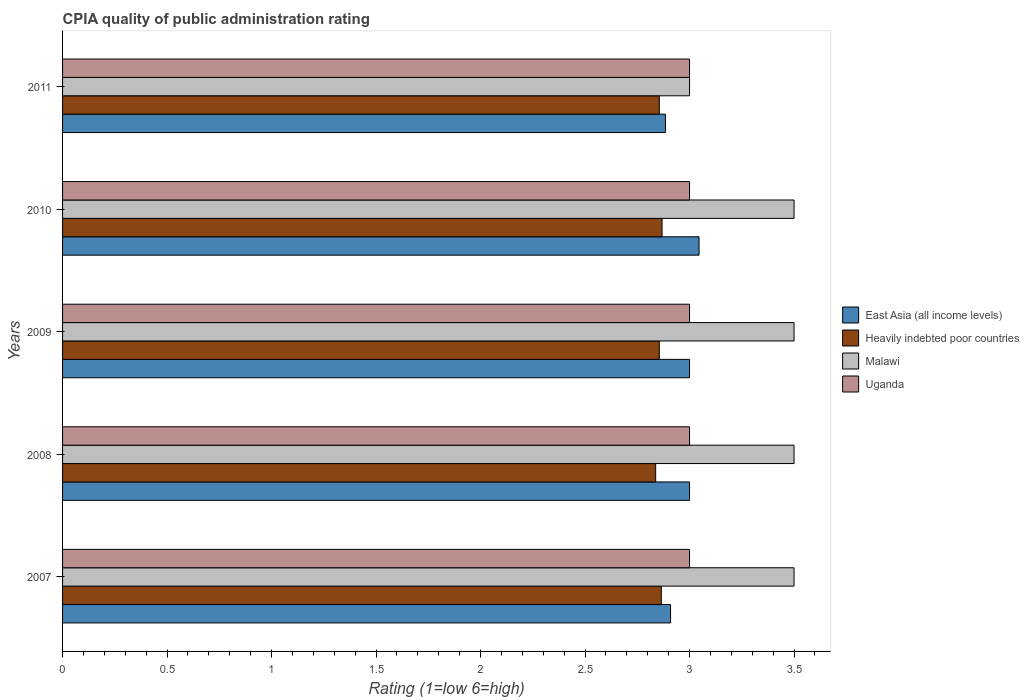Are the number of bars per tick equal to the number of legend labels?
Ensure brevity in your answer.  Yes. How many bars are there on the 4th tick from the top?
Give a very brief answer. 4. Across all years, what is the maximum CPIA rating in Heavily indebted poor countries?
Ensure brevity in your answer.  2.87. Across all years, what is the minimum CPIA rating in Malawi?
Provide a short and direct response. 3. In which year was the CPIA rating in Heavily indebted poor countries minimum?
Your answer should be very brief. 2008. What is the total CPIA rating in Uganda in the graph?
Your answer should be very brief. 15. In the year 2010, what is the difference between the CPIA rating in East Asia (all income levels) and CPIA rating in Heavily indebted poor countries?
Give a very brief answer. 0.18. In how many years, is the CPIA rating in Uganda greater than 1.4 ?
Ensure brevity in your answer.  5. Is the CPIA rating in East Asia (all income levels) in 2008 less than that in 2011?
Give a very brief answer. No. What is the difference between the highest and the second highest CPIA rating in Malawi?
Offer a very short reply. 0. Is it the case that in every year, the sum of the CPIA rating in Malawi and CPIA rating in Uganda is greater than the sum of CPIA rating in East Asia (all income levels) and CPIA rating in Heavily indebted poor countries?
Your answer should be very brief. Yes. What does the 2nd bar from the top in 2007 represents?
Provide a short and direct response. Malawi. What does the 2nd bar from the bottom in 2010 represents?
Provide a short and direct response. Heavily indebted poor countries. How many bars are there?
Give a very brief answer. 20. How many years are there in the graph?
Give a very brief answer. 5. What is the difference between two consecutive major ticks on the X-axis?
Ensure brevity in your answer.  0.5. Are the values on the major ticks of X-axis written in scientific E-notation?
Make the answer very short. No. Does the graph contain any zero values?
Provide a short and direct response. No. Does the graph contain grids?
Offer a very short reply. No. Where does the legend appear in the graph?
Offer a terse response. Center right. How many legend labels are there?
Your answer should be compact. 4. What is the title of the graph?
Your answer should be compact. CPIA quality of public administration rating. What is the label or title of the X-axis?
Provide a succinct answer. Rating (1=low 6=high). What is the label or title of the Y-axis?
Offer a terse response. Years. What is the Rating (1=low 6=high) in East Asia (all income levels) in 2007?
Make the answer very short. 2.91. What is the Rating (1=low 6=high) in Heavily indebted poor countries in 2007?
Offer a very short reply. 2.86. What is the Rating (1=low 6=high) in Uganda in 2007?
Your answer should be compact. 3. What is the Rating (1=low 6=high) in East Asia (all income levels) in 2008?
Your answer should be very brief. 3. What is the Rating (1=low 6=high) in Heavily indebted poor countries in 2008?
Offer a very short reply. 2.84. What is the Rating (1=low 6=high) in Malawi in 2008?
Provide a succinct answer. 3.5. What is the Rating (1=low 6=high) of Uganda in 2008?
Provide a succinct answer. 3. What is the Rating (1=low 6=high) in East Asia (all income levels) in 2009?
Make the answer very short. 3. What is the Rating (1=low 6=high) of Heavily indebted poor countries in 2009?
Offer a terse response. 2.86. What is the Rating (1=low 6=high) of East Asia (all income levels) in 2010?
Give a very brief answer. 3.05. What is the Rating (1=low 6=high) in Heavily indebted poor countries in 2010?
Make the answer very short. 2.87. What is the Rating (1=low 6=high) in Malawi in 2010?
Provide a succinct answer. 3.5. What is the Rating (1=low 6=high) of East Asia (all income levels) in 2011?
Make the answer very short. 2.88. What is the Rating (1=low 6=high) of Heavily indebted poor countries in 2011?
Your answer should be compact. 2.86. What is the Rating (1=low 6=high) of Uganda in 2011?
Ensure brevity in your answer.  3. Across all years, what is the maximum Rating (1=low 6=high) of East Asia (all income levels)?
Provide a succinct answer. 3.05. Across all years, what is the maximum Rating (1=low 6=high) in Heavily indebted poor countries?
Provide a short and direct response. 2.87. Across all years, what is the minimum Rating (1=low 6=high) of East Asia (all income levels)?
Ensure brevity in your answer.  2.88. Across all years, what is the minimum Rating (1=low 6=high) in Heavily indebted poor countries?
Make the answer very short. 2.84. Across all years, what is the minimum Rating (1=low 6=high) in Uganda?
Offer a terse response. 3. What is the total Rating (1=low 6=high) in East Asia (all income levels) in the graph?
Give a very brief answer. 14.84. What is the total Rating (1=low 6=high) of Heavily indebted poor countries in the graph?
Ensure brevity in your answer.  14.28. What is the total Rating (1=low 6=high) in Malawi in the graph?
Your answer should be very brief. 17. What is the difference between the Rating (1=low 6=high) of East Asia (all income levels) in 2007 and that in 2008?
Make the answer very short. -0.09. What is the difference between the Rating (1=low 6=high) in Heavily indebted poor countries in 2007 and that in 2008?
Provide a succinct answer. 0.03. What is the difference between the Rating (1=low 6=high) in East Asia (all income levels) in 2007 and that in 2009?
Your answer should be very brief. -0.09. What is the difference between the Rating (1=low 6=high) of Heavily indebted poor countries in 2007 and that in 2009?
Offer a very short reply. 0.01. What is the difference between the Rating (1=low 6=high) in East Asia (all income levels) in 2007 and that in 2010?
Ensure brevity in your answer.  -0.14. What is the difference between the Rating (1=low 6=high) of Heavily indebted poor countries in 2007 and that in 2010?
Your response must be concise. -0. What is the difference between the Rating (1=low 6=high) of Malawi in 2007 and that in 2010?
Give a very brief answer. 0. What is the difference between the Rating (1=low 6=high) in Uganda in 2007 and that in 2010?
Offer a very short reply. 0. What is the difference between the Rating (1=low 6=high) of East Asia (all income levels) in 2007 and that in 2011?
Give a very brief answer. 0.02. What is the difference between the Rating (1=low 6=high) of Heavily indebted poor countries in 2007 and that in 2011?
Make the answer very short. 0.01. What is the difference between the Rating (1=low 6=high) of Uganda in 2007 and that in 2011?
Your answer should be very brief. 0. What is the difference between the Rating (1=low 6=high) in East Asia (all income levels) in 2008 and that in 2009?
Your answer should be very brief. 0. What is the difference between the Rating (1=low 6=high) in Heavily indebted poor countries in 2008 and that in 2009?
Keep it short and to the point. -0.02. What is the difference between the Rating (1=low 6=high) in Malawi in 2008 and that in 2009?
Offer a terse response. 0. What is the difference between the Rating (1=low 6=high) of East Asia (all income levels) in 2008 and that in 2010?
Your answer should be very brief. -0.05. What is the difference between the Rating (1=low 6=high) in Heavily indebted poor countries in 2008 and that in 2010?
Give a very brief answer. -0.03. What is the difference between the Rating (1=low 6=high) of East Asia (all income levels) in 2008 and that in 2011?
Offer a terse response. 0.12. What is the difference between the Rating (1=low 6=high) of Heavily indebted poor countries in 2008 and that in 2011?
Provide a short and direct response. -0.02. What is the difference between the Rating (1=low 6=high) of East Asia (all income levels) in 2009 and that in 2010?
Provide a short and direct response. -0.05. What is the difference between the Rating (1=low 6=high) of Heavily indebted poor countries in 2009 and that in 2010?
Your response must be concise. -0.01. What is the difference between the Rating (1=low 6=high) in Malawi in 2009 and that in 2010?
Ensure brevity in your answer.  0. What is the difference between the Rating (1=low 6=high) in East Asia (all income levels) in 2009 and that in 2011?
Ensure brevity in your answer.  0.12. What is the difference between the Rating (1=low 6=high) in Heavily indebted poor countries in 2009 and that in 2011?
Provide a short and direct response. 0. What is the difference between the Rating (1=low 6=high) of Uganda in 2009 and that in 2011?
Your answer should be very brief. 0. What is the difference between the Rating (1=low 6=high) in East Asia (all income levels) in 2010 and that in 2011?
Your response must be concise. 0.16. What is the difference between the Rating (1=low 6=high) of Heavily indebted poor countries in 2010 and that in 2011?
Make the answer very short. 0.01. What is the difference between the Rating (1=low 6=high) of East Asia (all income levels) in 2007 and the Rating (1=low 6=high) of Heavily indebted poor countries in 2008?
Your response must be concise. 0.07. What is the difference between the Rating (1=low 6=high) of East Asia (all income levels) in 2007 and the Rating (1=low 6=high) of Malawi in 2008?
Your answer should be compact. -0.59. What is the difference between the Rating (1=low 6=high) of East Asia (all income levels) in 2007 and the Rating (1=low 6=high) of Uganda in 2008?
Your answer should be compact. -0.09. What is the difference between the Rating (1=low 6=high) of Heavily indebted poor countries in 2007 and the Rating (1=low 6=high) of Malawi in 2008?
Provide a short and direct response. -0.64. What is the difference between the Rating (1=low 6=high) in Heavily indebted poor countries in 2007 and the Rating (1=low 6=high) in Uganda in 2008?
Keep it short and to the point. -0.14. What is the difference between the Rating (1=low 6=high) of Malawi in 2007 and the Rating (1=low 6=high) of Uganda in 2008?
Ensure brevity in your answer.  0.5. What is the difference between the Rating (1=low 6=high) in East Asia (all income levels) in 2007 and the Rating (1=low 6=high) in Heavily indebted poor countries in 2009?
Your answer should be compact. 0.05. What is the difference between the Rating (1=low 6=high) of East Asia (all income levels) in 2007 and the Rating (1=low 6=high) of Malawi in 2009?
Your answer should be very brief. -0.59. What is the difference between the Rating (1=low 6=high) of East Asia (all income levels) in 2007 and the Rating (1=low 6=high) of Uganda in 2009?
Keep it short and to the point. -0.09. What is the difference between the Rating (1=low 6=high) in Heavily indebted poor countries in 2007 and the Rating (1=low 6=high) in Malawi in 2009?
Give a very brief answer. -0.64. What is the difference between the Rating (1=low 6=high) in Heavily indebted poor countries in 2007 and the Rating (1=low 6=high) in Uganda in 2009?
Your answer should be very brief. -0.14. What is the difference between the Rating (1=low 6=high) in Malawi in 2007 and the Rating (1=low 6=high) in Uganda in 2009?
Make the answer very short. 0.5. What is the difference between the Rating (1=low 6=high) in East Asia (all income levels) in 2007 and the Rating (1=low 6=high) in Heavily indebted poor countries in 2010?
Give a very brief answer. 0.04. What is the difference between the Rating (1=low 6=high) of East Asia (all income levels) in 2007 and the Rating (1=low 6=high) of Malawi in 2010?
Ensure brevity in your answer.  -0.59. What is the difference between the Rating (1=low 6=high) of East Asia (all income levels) in 2007 and the Rating (1=low 6=high) of Uganda in 2010?
Keep it short and to the point. -0.09. What is the difference between the Rating (1=low 6=high) in Heavily indebted poor countries in 2007 and the Rating (1=low 6=high) in Malawi in 2010?
Offer a terse response. -0.64. What is the difference between the Rating (1=low 6=high) in Heavily indebted poor countries in 2007 and the Rating (1=low 6=high) in Uganda in 2010?
Your answer should be compact. -0.14. What is the difference between the Rating (1=low 6=high) in Malawi in 2007 and the Rating (1=low 6=high) in Uganda in 2010?
Provide a succinct answer. 0.5. What is the difference between the Rating (1=low 6=high) in East Asia (all income levels) in 2007 and the Rating (1=low 6=high) in Heavily indebted poor countries in 2011?
Provide a short and direct response. 0.05. What is the difference between the Rating (1=low 6=high) in East Asia (all income levels) in 2007 and the Rating (1=low 6=high) in Malawi in 2011?
Ensure brevity in your answer.  -0.09. What is the difference between the Rating (1=low 6=high) in East Asia (all income levels) in 2007 and the Rating (1=low 6=high) in Uganda in 2011?
Give a very brief answer. -0.09. What is the difference between the Rating (1=low 6=high) of Heavily indebted poor countries in 2007 and the Rating (1=low 6=high) of Malawi in 2011?
Provide a succinct answer. -0.14. What is the difference between the Rating (1=low 6=high) in Heavily indebted poor countries in 2007 and the Rating (1=low 6=high) in Uganda in 2011?
Your response must be concise. -0.14. What is the difference between the Rating (1=low 6=high) in East Asia (all income levels) in 2008 and the Rating (1=low 6=high) in Heavily indebted poor countries in 2009?
Provide a short and direct response. 0.14. What is the difference between the Rating (1=low 6=high) of East Asia (all income levels) in 2008 and the Rating (1=low 6=high) of Uganda in 2009?
Your answer should be compact. 0. What is the difference between the Rating (1=low 6=high) in Heavily indebted poor countries in 2008 and the Rating (1=low 6=high) in Malawi in 2009?
Provide a short and direct response. -0.66. What is the difference between the Rating (1=low 6=high) in Heavily indebted poor countries in 2008 and the Rating (1=low 6=high) in Uganda in 2009?
Give a very brief answer. -0.16. What is the difference between the Rating (1=low 6=high) in Malawi in 2008 and the Rating (1=low 6=high) in Uganda in 2009?
Your response must be concise. 0.5. What is the difference between the Rating (1=low 6=high) in East Asia (all income levels) in 2008 and the Rating (1=low 6=high) in Heavily indebted poor countries in 2010?
Keep it short and to the point. 0.13. What is the difference between the Rating (1=low 6=high) in Heavily indebted poor countries in 2008 and the Rating (1=low 6=high) in Malawi in 2010?
Provide a succinct answer. -0.66. What is the difference between the Rating (1=low 6=high) of Heavily indebted poor countries in 2008 and the Rating (1=low 6=high) of Uganda in 2010?
Keep it short and to the point. -0.16. What is the difference between the Rating (1=low 6=high) of East Asia (all income levels) in 2008 and the Rating (1=low 6=high) of Heavily indebted poor countries in 2011?
Offer a terse response. 0.14. What is the difference between the Rating (1=low 6=high) in East Asia (all income levels) in 2008 and the Rating (1=low 6=high) in Uganda in 2011?
Provide a succinct answer. 0. What is the difference between the Rating (1=low 6=high) of Heavily indebted poor countries in 2008 and the Rating (1=low 6=high) of Malawi in 2011?
Ensure brevity in your answer.  -0.16. What is the difference between the Rating (1=low 6=high) of Heavily indebted poor countries in 2008 and the Rating (1=low 6=high) of Uganda in 2011?
Offer a very short reply. -0.16. What is the difference between the Rating (1=low 6=high) in East Asia (all income levels) in 2009 and the Rating (1=low 6=high) in Heavily indebted poor countries in 2010?
Your response must be concise. 0.13. What is the difference between the Rating (1=low 6=high) of Heavily indebted poor countries in 2009 and the Rating (1=low 6=high) of Malawi in 2010?
Provide a short and direct response. -0.64. What is the difference between the Rating (1=low 6=high) in Heavily indebted poor countries in 2009 and the Rating (1=low 6=high) in Uganda in 2010?
Give a very brief answer. -0.14. What is the difference between the Rating (1=low 6=high) in Malawi in 2009 and the Rating (1=low 6=high) in Uganda in 2010?
Your response must be concise. 0.5. What is the difference between the Rating (1=low 6=high) in East Asia (all income levels) in 2009 and the Rating (1=low 6=high) in Heavily indebted poor countries in 2011?
Your answer should be very brief. 0.14. What is the difference between the Rating (1=low 6=high) of Heavily indebted poor countries in 2009 and the Rating (1=low 6=high) of Malawi in 2011?
Your answer should be very brief. -0.14. What is the difference between the Rating (1=low 6=high) of Heavily indebted poor countries in 2009 and the Rating (1=low 6=high) of Uganda in 2011?
Your response must be concise. -0.14. What is the difference between the Rating (1=low 6=high) of East Asia (all income levels) in 2010 and the Rating (1=low 6=high) of Heavily indebted poor countries in 2011?
Offer a very short reply. 0.19. What is the difference between the Rating (1=low 6=high) in East Asia (all income levels) in 2010 and the Rating (1=low 6=high) in Malawi in 2011?
Make the answer very short. 0.05. What is the difference between the Rating (1=low 6=high) in East Asia (all income levels) in 2010 and the Rating (1=low 6=high) in Uganda in 2011?
Your answer should be very brief. 0.05. What is the difference between the Rating (1=low 6=high) of Heavily indebted poor countries in 2010 and the Rating (1=low 6=high) of Malawi in 2011?
Your answer should be compact. -0.13. What is the difference between the Rating (1=low 6=high) of Heavily indebted poor countries in 2010 and the Rating (1=low 6=high) of Uganda in 2011?
Provide a short and direct response. -0.13. What is the average Rating (1=low 6=high) of East Asia (all income levels) per year?
Give a very brief answer. 2.97. What is the average Rating (1=low 6=high) of Heavily indebted poor countries per year?
Offer a very short reply. 2.86. What is the average Rating (1=low 6=high) of Uganda per year?
Provide a succinct answer. 3. In the year 2007, what is the difference between the Rating (1=low 6=high) in East Asia (all income levels) and Rating (1=low 6=high) in Heavily indebted poor countries?
Your answer should be compact. 0.04. In the year 2007, what is the difference between the Rating (1=low 6=high) in East Asia (all income levels) and Rating (1=low 6=high) in Malawi?
Offer a terse response. -0.59. In the year 2007, what is the difference between the Rating (1=low 6=high) of East Asia (all income levels) and Rating (1=low 6=high) of Uganda?
Your answer should be very brief. -0.09. In the year 2007, what is the difference between the Rating (1=low 6=high) of Heavily indebted poor countries and Rating (1=low 6=high) of Malawi?
Make the answer very short. -0.64. In the year 2007, what is the difference between the Rating (1=low 6=high) of Heavily indebted poor countries and Rating (1=low 6=high) of Uganda?
Keep it short and to the point. -0.14. In the year 2007, what is the difference between the Rating (1=low 6=high) of Malawi and Rating (1=low 6=high) of Uganda?
Your answer should be compact. 0.5. In the year 2008, what is the difference between the Rating (1=low 6=high) of East Asia (all income levels) and Rating (1=low 6=high) of Heavily indebted poor countries?
Offer a very short reply. 0.16. In the year 2008, what is the difference between the Rating (1=low 6=high) of Heavily indebted poor countries and Rating (1=low 6=high) of Malawi?
Your answer should be compact. -0.66. In the year 2008, what is the difference between the Rating (1=low 6=high) in Heavily indebted poor countries and Rating (1=low 6=high) in Uganda?
Ensure brevity in your answer.  -0.16. In the year 2009, what is the difference between the Rating (1=low 6=high) of East Asia (all income levels) and Rating (1=low 6=high) of Heavily indebted poor countries?
Give a very brief answer. 0.14. In the year 2009, what is the difference between the Rating (1=low 6=high) in East Asia (all income levels) and Rating (1=low 6=high) in Uganda?
Ensure brevity in your answer.  0. In the year 2009, what is the difference between the Rating (1=low 6=high) of Heavily indebted poor countries and Rating (1=low 6=high) of Malawi?
Your response must be concise. -0.64. In the year 2009, what is the difference between the Rating (1=low 6=high) in Heavily indebted poor countries and Rating (1=low 6=high) in Uganda?
Keep it short and to the point. -0.14. In the year 2009, what is the difference between the Rating (1=low 6=high) of Malawi and Rating (1=low 6=high) of Uganda?
Make the answer very short. 0.5. In the year 2010, what is the difference between the Rating (1=low 6=high) in East Asia (all income levels) and Rating (1=low 6=high) in Heavily indebted poor countries?
Provide a short and direct response. 0.18. In the year 2010, what is the difference between the Rating (1=low 6=high) in East Asia (all income levels) and Rating (1=low 6=high) in Malawi?
Provide a short and direct response. -0.45. In the year 2010, what is the difference between the Rating (1=low 6=high) in East Asia (all income levels) and Rating (1=low 6=high) in Uganda?
Your answer should be compact. 0.05. In the year 2010, what is the difference between the Rating (1=low 6=high) in Heavily indebted poor countries and Rating (1=low 6=high) in Malawi?
Your answer should be compact. -0.63. In the year 2010, what is the difference between the Rating (1=low 6=high) in Heavily indebted poor countries and Rating (1=low 6=high) in Uganda?
Ensure brevity in your answer.  -0.13. In the year 2010, what is the difference between the Rating (1=low 6=high) of Malawi and Rating (1=low 6=high) of Uganda?
Give a very brief answer. 0.5. In the year 2011, what is the difference between the Rating (1=low 6=high) in East Asia (all income levels) and Rating (1=low 6=high) in Heavily indebted poor countries?
Give a very brief answer. 0.03. In the year 2011, what is the difference between the Rating (1=low 6=high) in East Asia (all income levels) and Rating (1=low 6=high) in Malawi?
Make the answer very short. -0.12. In the year 2011, what is the difference between the Rating (1=low 6=high) of East Asia (all income levels) and Rating (1=low 6=high) of Uganda?
Your answer should be very brief. -0.12. In the year 2011, what is the difference between the Rating (1=low 6=high) in Heavily indebted poor countries and Rating (1=low 6=high) in Malawi?
Give a very brief answer. -0.14. In the year 2011, what is the difference between the Rating (1=low 6=high) of Heavily indebted poor countries and Rating (1=low 6=high) of Uganda?
Your response must be concise. -0.14. In the year 2011, what is the difference between the Rating (1=low 6=high) in Malawi and Rating (1=low 6=high) in Uganda?
Offer a terse response. 0. What is the ratio of the Rating (1=low 6=high) of East Asia (all income levels) in 2007 to that in 2008?
Offer a very short reply. 0.97. What is the ratio of the Rating (1=low 6=high) of Heavily indebted poor countries in 2007 to that in 2008?
Provide a succinct answer. 1.01. What is the ratio of the Rating (1=low 6=high) in Malawi in 2007 to that in 2008?
Give a very brief answer. 1. What is the ratio of the Rating (1=low 6=high) in East Asia (all income levels) in 2007 to that in 2009?
Your answer should be very brief. 0.97. What is the ratio of the Rating (1=low 6=high) of East Asia (all income levels) in 2007 to that in 2010?
Provide a succinct answer. 0.96. What is the ratio of the Rating (1=low 6=high) of Heavily indebted poor countries in 2007 to that in 2010?
Offer a very short reply. 1. What is the ratio of the Rating (1=low 6=high) in Uganda in 2007 to that in 2010?
Offer a terse response. 1. What is the ratio of the Rating (1=low 6=high) of East Asia (all income levels) in 2007 to that in 2011?
Give a very brief answer. 1.01. What is the ratio of the Rating (1=low 6=high) in Heavily indebted poor countries in 2007 to that in 2011?
Keep it short and to the point. 1. What is the ratio of the Rating (1=low 6=high) of Uganda in 2008 to that in 2009?
Your answer should be compact. 1. What is the ratio of the Rating (1=low 6=high) in East Asia (all income levels) in 2008 to that in 2010?
Provide a short and direct response. 0.99. What is the ratio of the Rating (1=low 6=high) in Heavily indebted poor countries in 2008 to that in 2010?
Your answer should be very brief. 0.99. What is the ratio of the Rating (1=low 6=high) of Uganda in 2008 to that in 2010?
Provide a succinct answer. 1. What is the ratio of the Rating (1=low 6=high) of Heavily indebted poor countries in 2008 to that in 2011?
Offer a terse response. 0.99. What is the ratio of the Rating (1=low 6=high) in Uganda in 2008 to that in 2011?
Offer a very short reply. 1. What is the ratio of the Rating (1=low 6=high) of East Asia (all income levels) in 2009 to that in 2010?
Offer a very short reply. 0.99. What is the ratio of the Rating (1=low 6=high) in Heavily indebted poor countries in 2009 to that in 2010?
Your answer should be compact. 1. What is the ratio of the Rating (1=low 6=high) in Uganda in 2009 to that in 2010?
Provide a succinct answer. 1. What is the ratio of the Rating (1=low 6=high) of East Asia (all income levels) in 2009 to that in 2011?
Offer a terse response. 1.04. What is the ratio of the Rating (1=low 6=high) in Malawi in 2009 to that in 2011?
Provide a short and direct response. 1.17. What is the ratio of the Rating (1=low 6=high) of Uganda in 2009 to that in 2011?
Ensure brevity in your answer.  1. What is the ratio of the Rating (1=low 6=high) in East Asia (all income levels) in 2010 to that in 2011?
Offer a terse response. 1.06. What is the ratio of the Rating (1=low 6=high) in Heavily indebted poor countries in 2010 to that in 2011?
Ensure brevity in your answer.  1. What is the difference between the highest and the second highest Rating (1=low 6=high) of East Asia (all income levels)?
Give a very brief answer. 0.05. What is the difference between the highest and the second highest Rating (1=low 6=high) in Heavily indebted poor countries?
Give a very brief answer. 0. What is the difference between the highest and the second highest Rating (1=low 6=high) of Uganda?
Give a very brief answer. 0. What is the difference between the highest and the lowest Rating (1=low 6=high) of East Asia (all income levels)?
Provide a succinct answer. 0.16. What is the difference between the highest and the lowest Rating (1=low 6=high) in Heavily indebted poor countries?
Give a very brief answer. 0.03. What is the difference between the highest and the lowest Rating (1=low 6=high) of Malawi?
Ensure brevity in your answer.  0.5. 